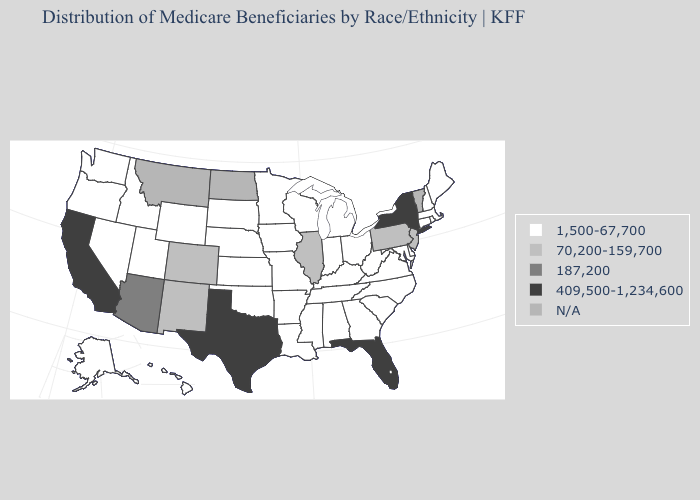Among the states that border Massachusetts , which have the lowest value?
Give a very brief answer. Connecticut, New Hampshire, Rhode Island. Does the first symbol in the legend represent the smallest category?
Concise answer only. Yes. Does New Mexico have the lowest value in the USA?
Concise answer only. No. Name the states that have a value in the range 1,500-67,700?
Keep it brief. Alabama, Alaska, Arkansas, Connecticut, Delaware, Georgia, Hawaii, Idaho, Indiana, Iowa, Kansas, Kentucky, Louisiana, Maine, Maryland, Massachusetts, Michigan, Minnesota, Mississippi, Missouri, Nebraska, Nevada, New Hampshire, North Carolina, Ohio, Oklahoma, Oregon, Rhode Island, South Carolina, South Dakota, Tennessee, Utah, Virginia, Washington, West Virginia, Wisconsin, Wyoming. Does the map have missing data?
Concise answer only. Yes. What is the lowest value in states that border South Carolina?
Give a very brief answer. 1,500-67,700. Does California have the highest value in the USA?
Quick response, please. Yes. What is the value of Montana?
Answer briefly. N/A. Name the states that have a value in the range 409,500-1,234,600?
Keep it brief. California, Florida, New York, Texas. What is the value of Michigan?
Be succinct. 1,500-67,700. What is the value of Ohio?
Keep it brief. 1,500-67,700. Name the states that have a value in the range N/A?
Answer briefly. Montana, North Dakota, Vermont. Name the states that have a value in the range 187,200?
Quick response, please. Arizona. Name the states that have a value in the range 1,500-67,700?
Quick response, please. Alabama, Alaska, Arkansas, Connecticut, Delaware, Georgia, Hawaii, Idaho, Indiana, Iowa, Kansas, Kentucky, Louisiana, Maine, Maryland, Massachusetts, Michigan, Minnesota, Mississippi, Missouri, Nebraska, Nevada, New Hampshire, North Carolina, Ohio, Oklahoma, Oregon, Rhode Island, South Carolina, South Dakota, Tennessee, Utah, Virginia, Washington, West Virginia, Wisconsin, Wyoming. 